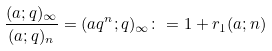<formula> <loc_0><loc_0><loc_500><loc_500>\frac { ( a ; q ) _ { \infty } } { ( a ; q ) _ { n } } = ( a q ^ { n } ; q ) _ { \infty } \colon = 1 + r _ { 1 } ( a ; n )</formula> 